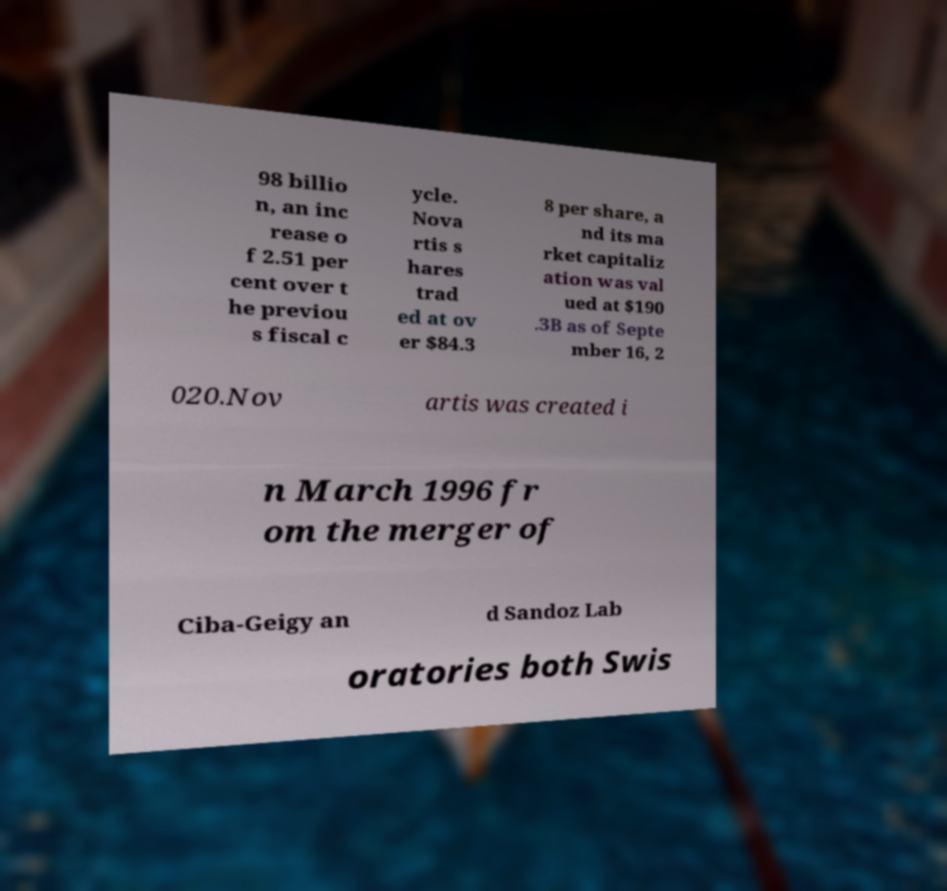Could you assist in decoding the text presented in this image and type it out clearly? 98 billio n, an inc rease o f 2.51 per cent over t he previou s fiscal c ycle. Nova rtis s hares trad ed at ov er $84.3 8 per share, a nd its ma rket capitaliz ation was val ued at $190 .3B as of Septe mber 16, 2 020.Nov artis was created i n March 1996 fr om the merger of Ciba-Geigy an d Sandoz Lab oratories both Swis 